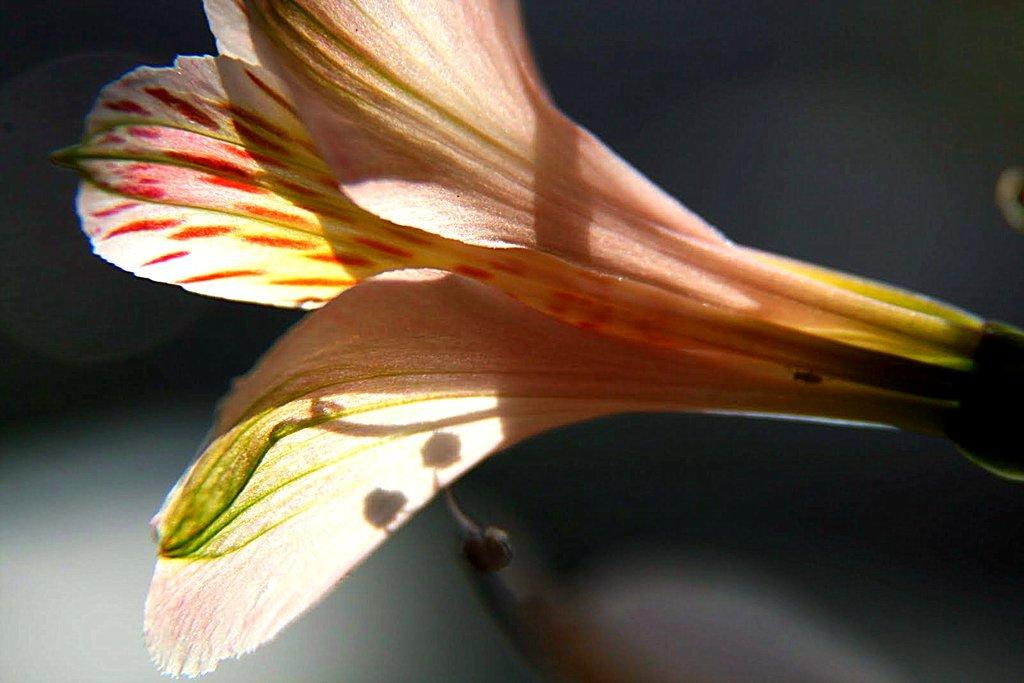What is the main subject of the picture? There is a flower in the picture. Can you describe the background of the image? The background of the image is blurred. How many pizzas are mentioned on the receipt in the image? There is no receipt or mention of pizzas in the image; it features a flower with a blurred background. 